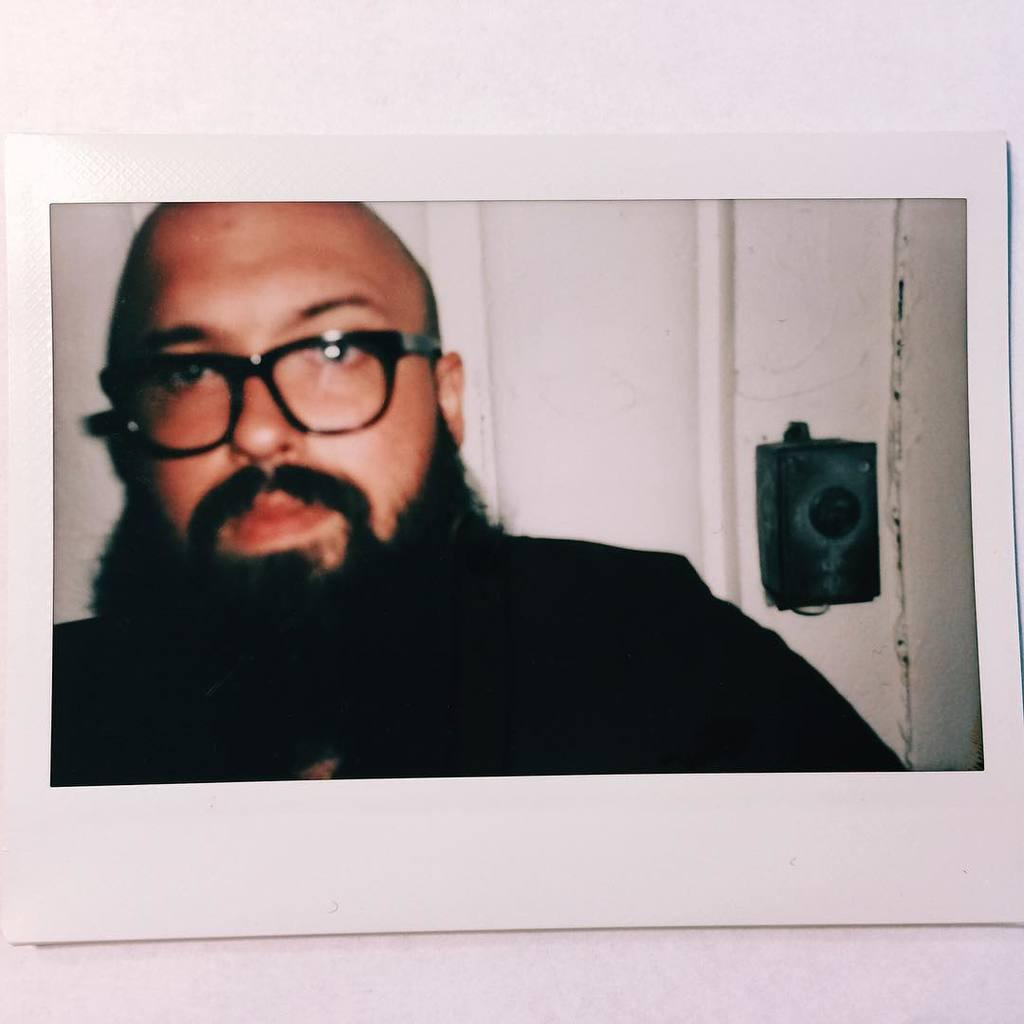What is the main subject of the image? The image contains a photograph. Can you describe the person in the photograph? There is a person with a beard in the photograph. What is visible behind the person in the photograph? There is a door behind the person in the photograph. What can be seen on the right side of the image? There is a black object on the right side of the image. What are the person's hands doing in the photograph? The provided facts do not mention the person's hands, so we cannot determine what they are doing in the photograph. 